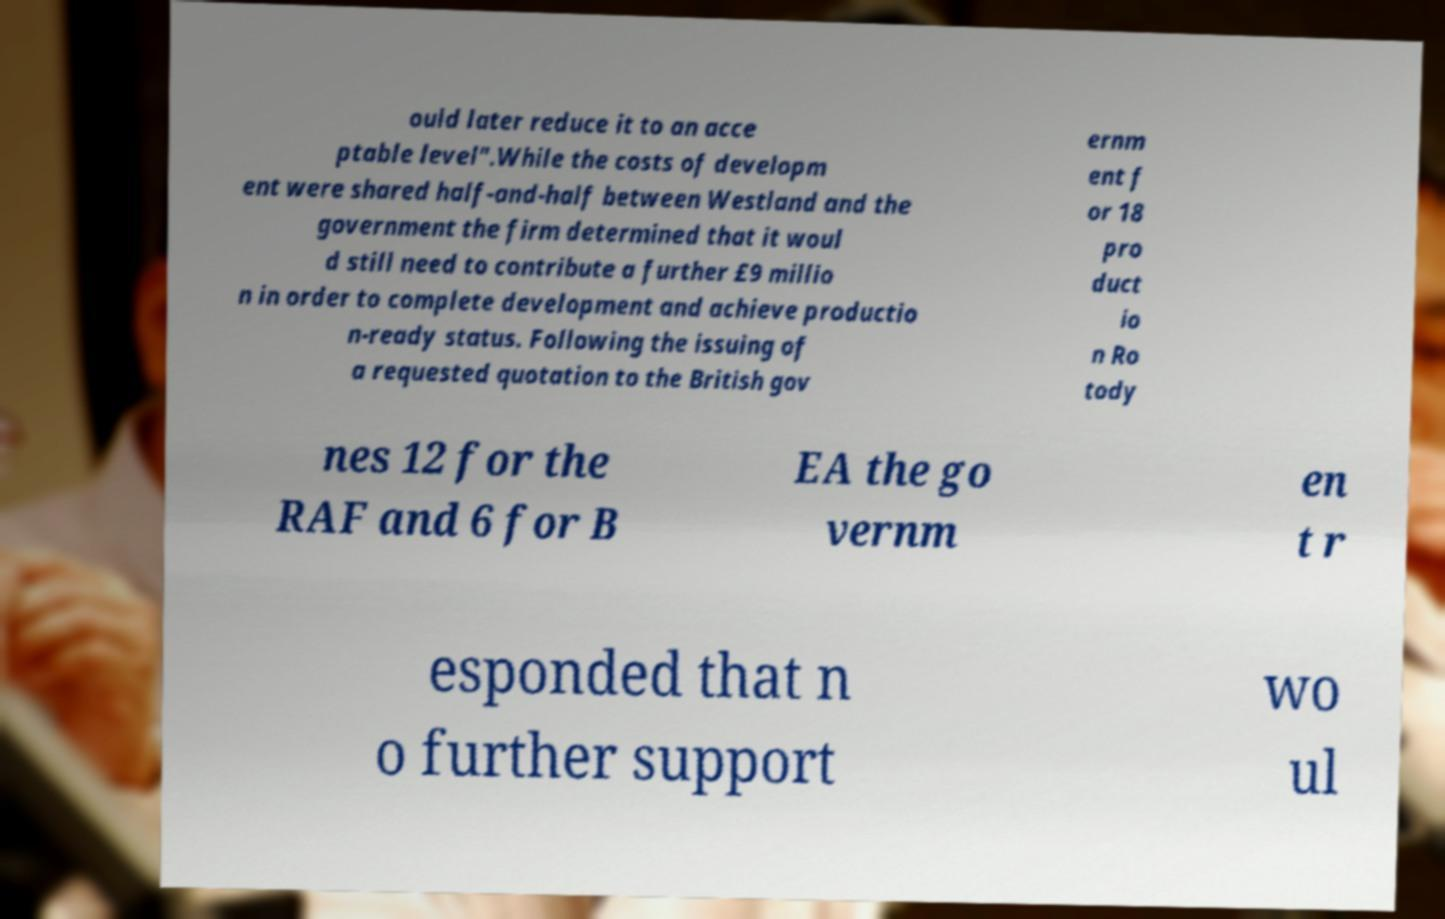For documentation purposes, I need the text within this image transcribed. Could you provide that? ould later reduce it to an acce ptable level".While the costs of developm ent were shared half-and-half between Westland and the government the firm determined that it woul d still need to contribute a further £9 millio n in order to complete development and achieve productio n-ready status. Following the issuing of a requested quotation to the British gov ernm ent f or 18 pro duct io n Ro tody nes 12 for the RAF and 6 for B EA the go vernm en t r esponded that n o further support wo ul 